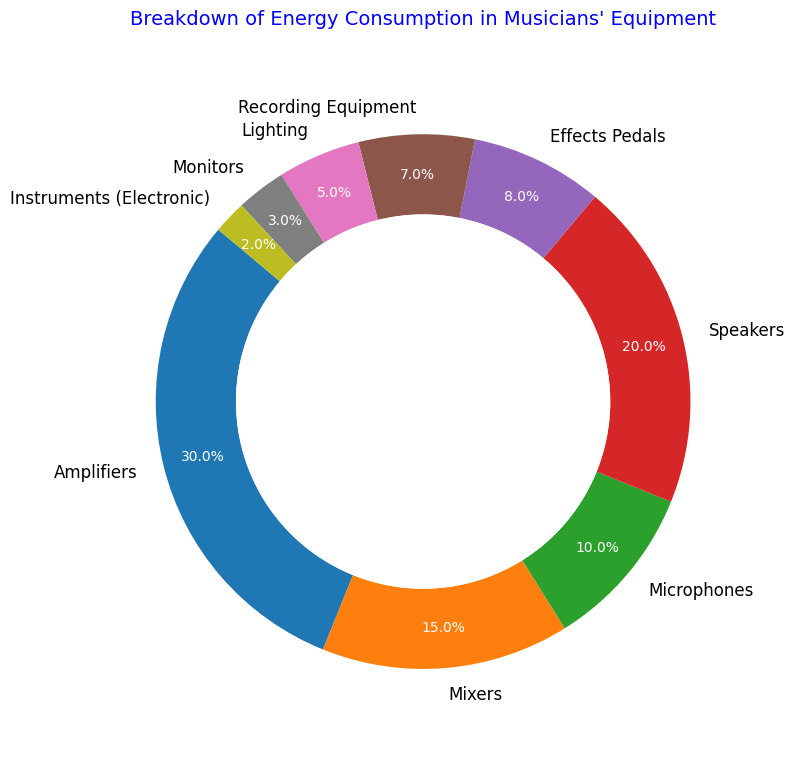Which piece of equipment has the highest energy consumption? The chart shows that amplifiers have the largest portion at 30%, making them the equipment with the highest energy consumption.
Answer: Amplifiers What is the combined energy consumption percentage of speakers and monitors? From the chart, speakers consume 20% and monitors consume 3%. Adding those together gives 20% + 3% = 23%.
Answer: 23% Are microphones more energy-consuming than effects pedals? According to the chart, microphones have a 10% energy consumption and effects pedals have 8%. So, microphones consume more energy.
Answer: Yes Which pieces of equipment together consume less energy than amplifiers alone? Amplifiers consume 30%. We look for combinations that total under 30%. Mixers (15%), microphones (10%), effects pedals (8%), recording equipment (7%), lighting (5%), monitors (3%), and instruments (electronic) (2%) all are each less than 30%. Combining them: e.g., recording equipment, lighting, and monitors: 7% + 5% + 3% = 15%, still less than 30%. Any combination of these segments adding up to less than 30% works.
Answer: Any single segment or combinations not exceeding 30% What is the difference in energy consumption percentage between speakers and lighting? The speakers consume 20% and the lighting consumes 5%. The difference is 20% - 5% = 15%.
Answer: 15% Which equipment falls between 5% and 15% energy consumption? The chart indicates that mixers (15%), microphones (10%), effects pedals (8%), and recording equipment (7%) all fall within the specified range.
Answer: Mixers, microphones, effects pedals, recording equipment What's the combined energy consumption percentage of the three least energy-consuming pieces of equipment? The three least consuming items are monitors (3%), instruments (electronic) (2%), and lighting (5%). Summing up the percentages: 3% + 2% + 5% = 10%.
Answer: 10% Is the consumption by mixers close to twice that of recording equipment? Mixers consume 15% and recording equipment 7%. Doubling the recording equipment's consumption: 7% * 2 = 14%, which is close to the mixer's 15%.
Answer: Yes What is the average energy consumption of recording equipment and microphones? Recording equipment has 7% and microphones have 10%. The average is (7% + 10%) / 2 = 8.5%.
Answer: 8.5% 